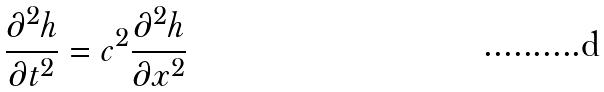<formula> <loc_0><loc_0><loc_500><loc_500>\frac { \partial ^ { 2 } h } { \partial t ^ { 2 } } = c ^ { 2 } \frac { \partial ^ { 2 } h } { \partial x ^ { 2 } }</formula> 